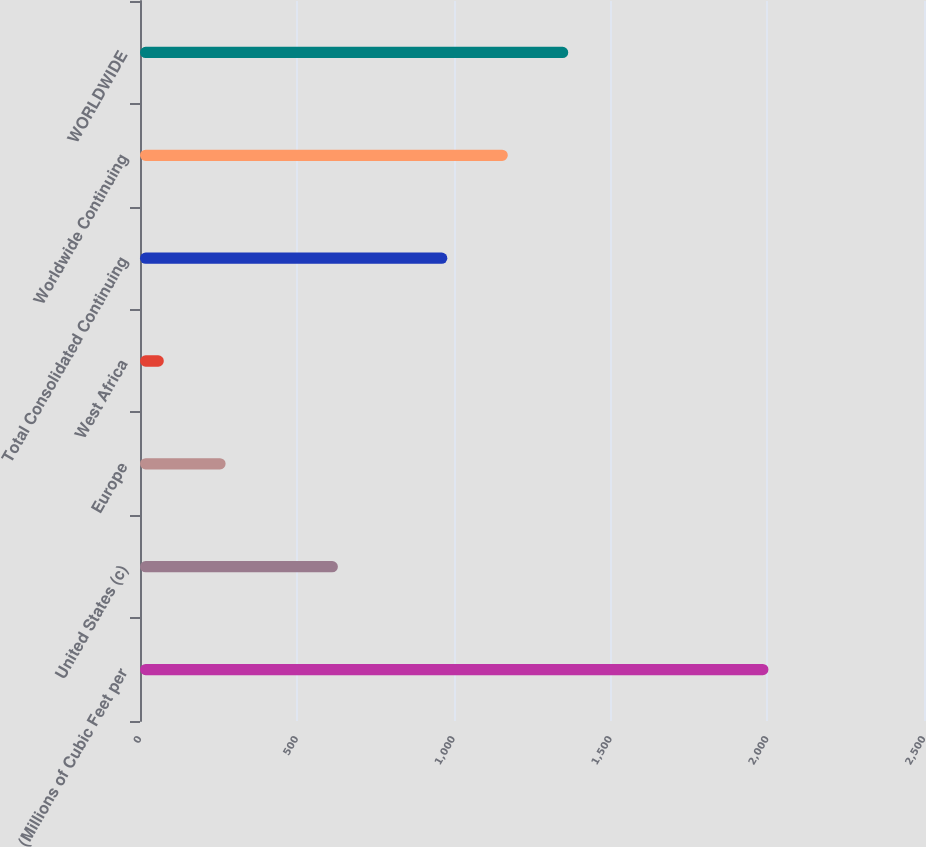Convert chart to OTSL. <chart><loc_0><loc_0><loc_500><loc_500><bar_chart><fcel>(Millions of Cubic Feet per<fcel>United States (c)<fcel>Europe<fcel>West Africa<fcel>Total Consolidated Continuing<fcel>Worldwide Continuing<fcel>WORLDWIDE<nl><fcel>2004<fcel>631<fcel>273<fcel>76<fcel>980<fcel>1172.8<fcel>1365.6<nl></chart> 